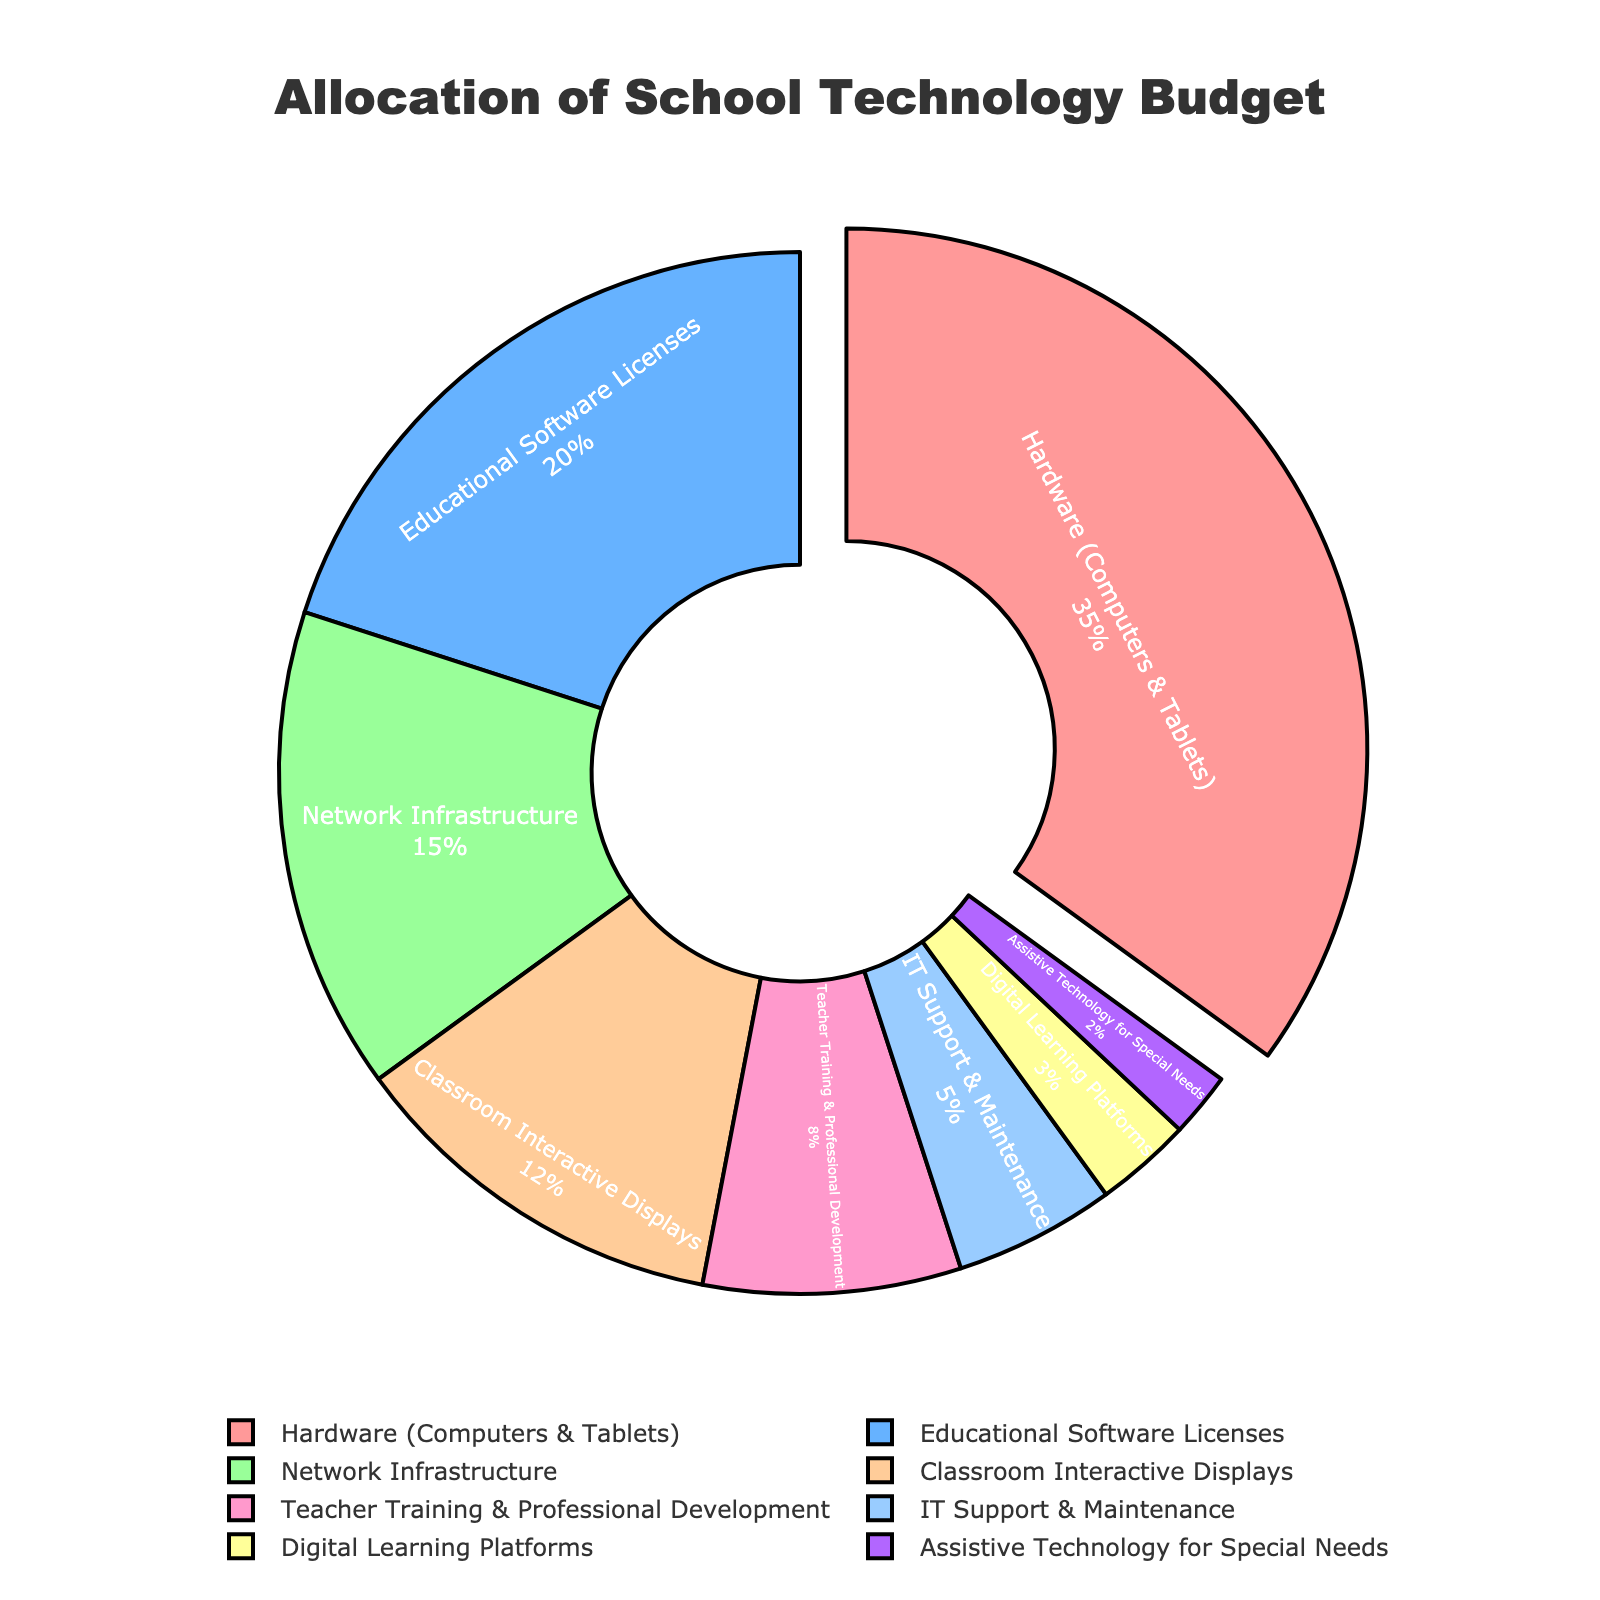What's the largest category of the school technology budget? The figure shows that the largest portion of the budget is allocated to "Hardware (Computers & Tablets)" with 35%. This is visually highlighted by being slightly pulled out from the pie chart.
Answer: Hardware (Computers & Tablets) Which category has the smallest allocation in the school technology budget? The smallest segment in the pie chart represents "Assistive Technology for Special Needs," which has a 2% allocation. This can be observed as the smallest slice in the pie chart.
Answer: Assistive Technology for Special Needs How does the allocation for Network Infrastructure compare to that for Teacher Training & Professional Development? The pie chart shows that Network Infrastructure has a 15% allocation, while Teacher Training & Professional Development has an 8% allocation. By comparing these percentages, Network Infrastructure receives a larger portion of the budget.
Answer: Network Infrastructure is larger What is the combined percentage of the budget allocated to Educational Software Licenses and Digital Learning Platforms? To find the combined percentage, you add the percentages for Educational Software Licenses (20%) and Digital Learning Platforms (3%). 20% + 3% = 23%
Answer: 23% How much more budget allocation does Hardware (Computers & Tablets) receive compared to IT Support & Maintenance? Hardware (Computers & Tablets) receives 35%, and IT Support & Maintenance receives 5%. The difference is 35% - 5% = 30%.
Answer: 30% Which categories of the budget have a combined allocation exceeding 50%? To find the combined allocation exceeding 50%, we first add the largest categories:
- Hardware (Computers & Tablets): 35%
- Educational Software Licenses: 20%
35% + 20% = 55%
Answer: Hardware (Computers & Tablets) and Educational Software Licenses What is the visual indicator for the category with the highest budget allocation? The visual indicator for the highest budget allocation is the slice being slightly pulled out from the pie. This happens for "Hardware (Computers & Tablets)" with 35%.
Answer: Pulled out slice If you combine the budgets for Classroom Interactive Displays and IT Support & Maintenance, will it be greater than Educational Software Licenses? Classroom Interactive Displays is 12% and IT Support & Maintenance is 5%. Combined they are 12% + 5% = 17%, which is less than Educational Software Licenses at 20%.
Answer: No 